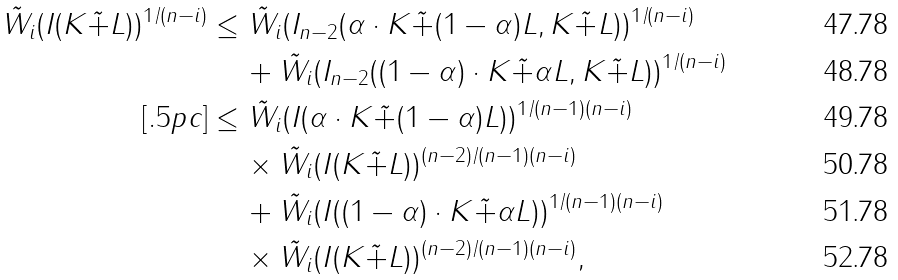<formula> <loc_0><loc_0><loc_500><loc_500>\tilde { W } _ { i } ( I ( K \tilde { + } L ) ) ^ { 1 / ( n - i ) } & \leq \tilde { W } _ { i } ( I _ { n - 2 } ( \alpha \cdot K \tilde { + } ( 1 - \alpha ) L , K \tilde { + } L ) ) ^ { 1 / ( n - i ) } \\ & \quad \, + \tilde { W } _ { i } ( I _ { n - 2 } ( ( 1 - \alpha ) \cdot K \tilde { + } \alpha L , K \tilde { + } L ) ) ^ { 1 / ( n - i ) } \\ [ . 5 p c ] & \leq \tilde { W } _ { i } ( I ( \alpha \cdot K \tilde { + } ( 1 - \alpha ) L ) ) ^ { 1 / ( n - 1 ) ( n - i ) } \\ & \quad \, \times \tilde { W } _ { i } ( I ( K \tilde { + } L ) ) ^ { ( n - 2 ) / ( n - 1 ) ( n - i ) } \\ & \quad \, + \tilde { W } _ { i } ( I ( ( 1 - \alpha ) \cdot K \tilde { + } \alpha L ) ) ^ { 1 / ( n - 1 ) ( n - i ) } \\ & \quad \, \times \tilde { W } _ { i } ( I ( K \tilde { + } L ) ) ^ { ( n - 2 ) / ( n - 1 ) ( n - i ) } ,</formula> 